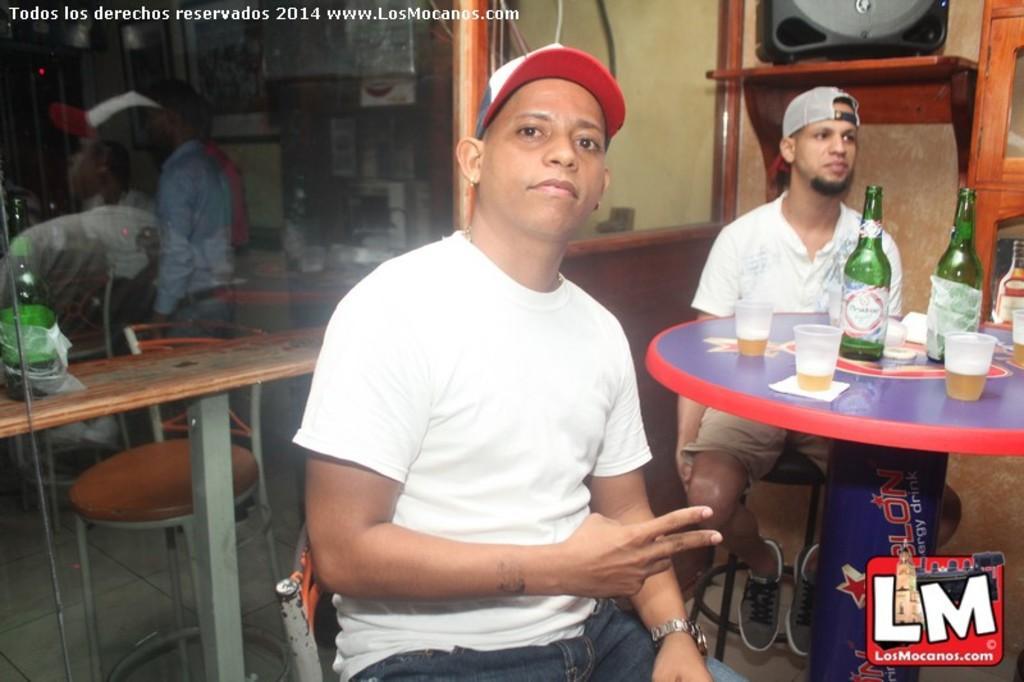In one or two sentences, can you explain what this image depicts? In this image there is a person who is sitting on a chair and he is wearing a white t-shirt and blue jeans. On the right side there is an another person who is wearing a grey color cap. On the table there are two wine bottle and three wine glasses. On the left side we can see a reflection of a person in a mirror. 